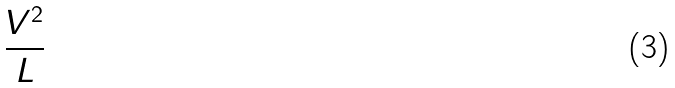Convert formula to latex. <formula><loc_0><loc_0><loc_500><loc_500>\frac { V ^ { 2 } } { L }</formula> 